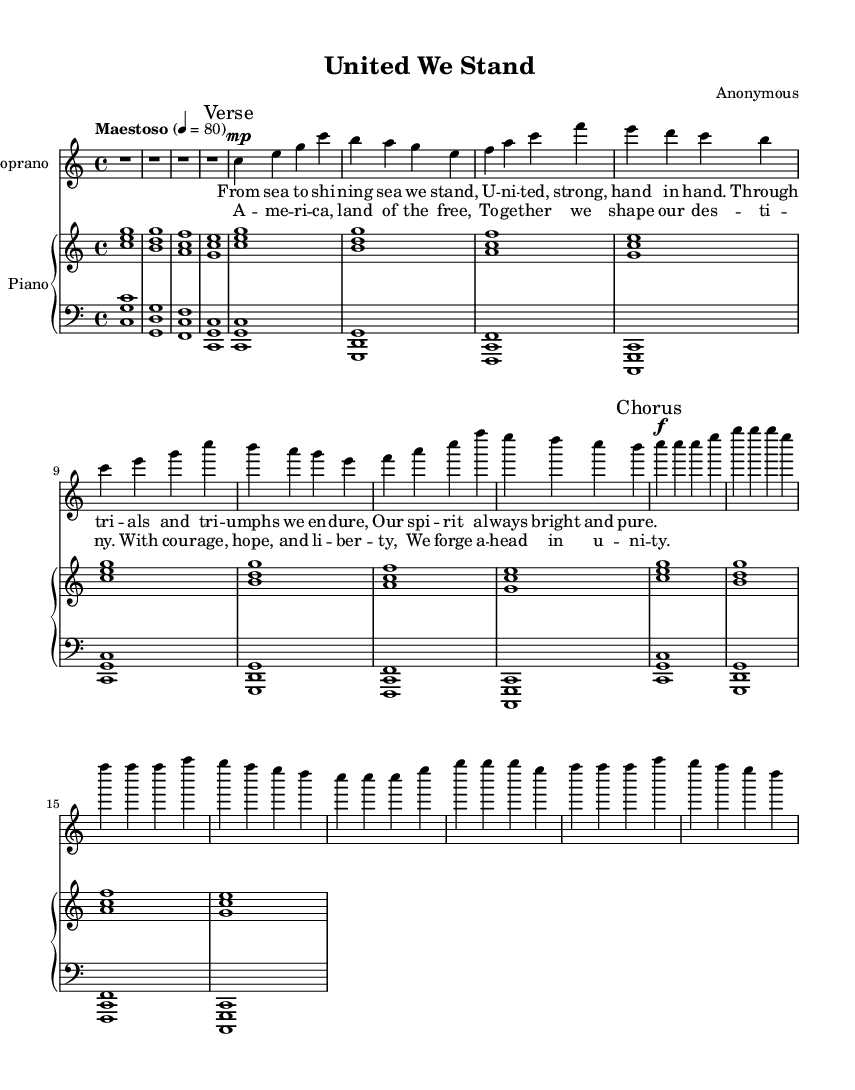what is the key signature of this music? The key signature is C major, which is indicated by the absence of sharps or flats in the music notation.
Answer: C major what is the time signature of this music? The time signature is indicated at the beginning of the score as 4/4, meaning there are four beats in each measure and the quarter note receives one beat.
Answer: 4/4 what is the tempo marking of this composition? The tempo marking is specified as "Maestoso" with a metronome marking of 80, suggesting a majestic and stately pace.
Answer: Maestoso how many verses are there in the composition? The sheet music includes a single verse indicated by the marking "Verse," followed by a chorus, indicating a structure of one verse and a repeating chorus.
Answer: One verse what is the dynamic marking for the chorus? The dynamic marking for the chorus is indicated as "f," which stands for forte, suggesting that this section should be played loudly.
Answer: forte what is the theme of the lyrics? The lyrics celebrate American resilience and unity, expressing strength in adversity and the spirit of togetherness among citizens.
Answer: Resilience and unity how is the accompaniment structured for the piano? The accompaniment includes a right-hand part playing chords in harmony with the melody and a left-hand part providing a bass foundation with specific chord voicings, creating a rich texture.
Answer: Two-part harmony 